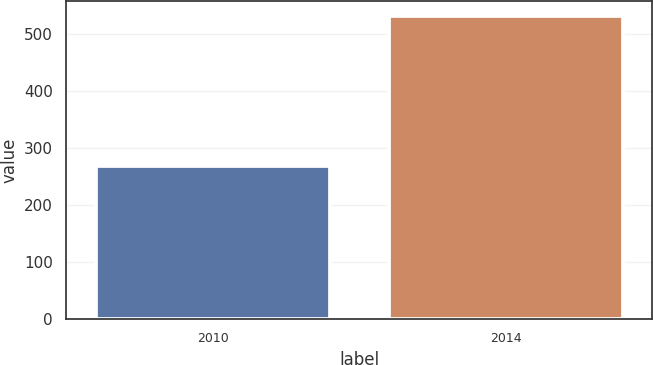Convert chart to OTSL. <chart><loc_0><loc_0><loc_500><loc_500><bar_chart><fcel>2010<fcel>2014<nl><fcel>268<fcel>531<nl></chart> 